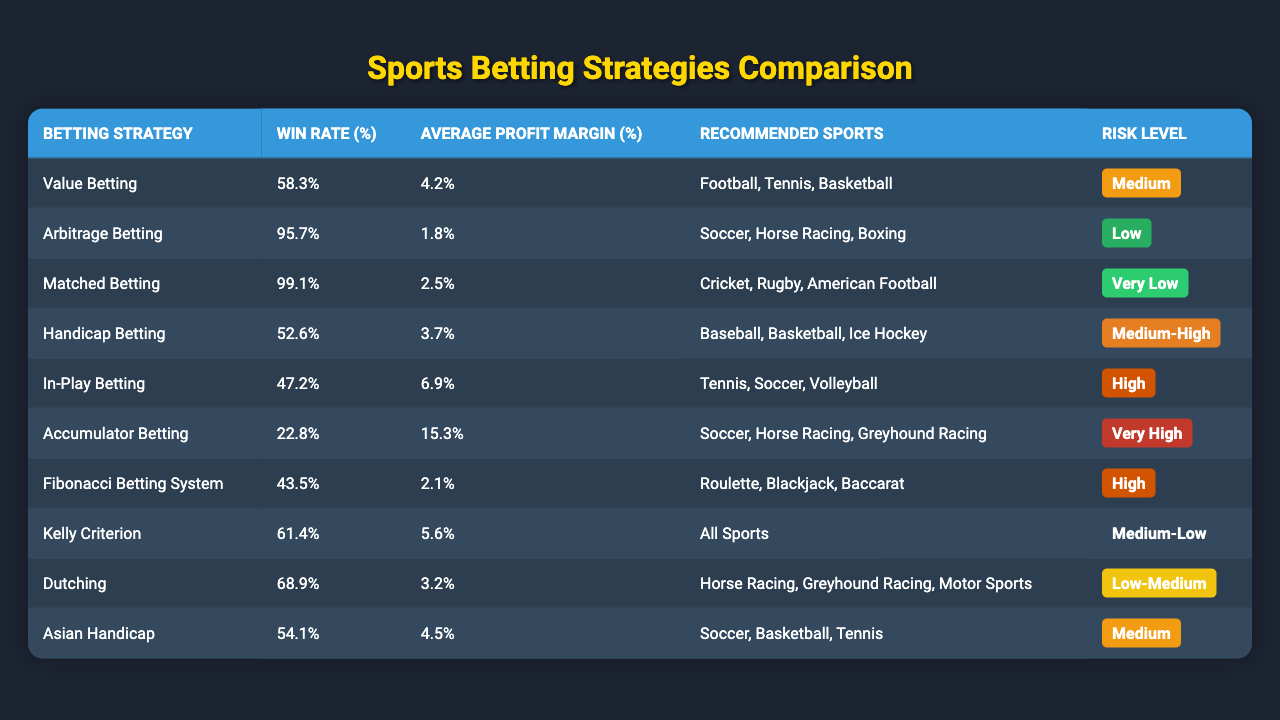What is the win rate of the Matched Betting strategy? The win rate for the Matched Betting strategy is given directly in the table next to its name, which is 99.1%.
Answer: 99.1% Which betting strategy has the highest average profit margin? By comparing the average profit margins listed in the table, the Accumulator Betting strategy has the highest profit margin at 15.3%.
Answer: 15.3% Is the Risk Level for Arbitrage Betting low? The table indicates that the Risk Level for Arbitrage Betting is marked as "Low."
Answer: Yes What is the average win rate for strategies categorized as Low Risk? The win rates for Low Risk strategies are from Arbitrage Betting (95.7%) and Dutching (68.9%). Calculating the average: (95.7 + 68.9) / 2 = 82.3%.
Answer: 82.3% Which betting strategy has the lowest win rate and what is that rate? From the table, the Accumulator Betting strategy has the lowest win rate, at 22.8%.
Answer: 22.8% What are the recommended sports for the Kelly Criterion betting strategy? The table shows that the recommended sports for the Kelly Criterion are "All Sports."
Answer: All Sports If you want a strategy with at least a 60% win rate and medium risk, which one should you choose? Looking at the table, the strategies that meet these criteria are Value Betting (58.3%) and Kelly Criterion (61.4%). The only one that meets both criteria is the Kelly Criterion, which has a win rate of 61.4%.
Answer: Kelly Criterion Which strategy has a win rate of 47.2% and what is its risk level? The In-Play Betting strategy has a win rate of 47.2%, and its risk level is categorized as High according to the table.
Answer: High Are there any betting strategies related to horse racing that have high win rates? The strategies related to horse racing are Arbitrage Betting (95.7%) and Dutching (68.9%), both of which have high win rates.
Answer: Yes What is the difference in win rates between the Matched Betting and Value Betting strategies? The Matched Betting strategy has a win rate of 99.1%, while the Value Betting strategy has a win rate of 58.3%. The difference is calculated as 99.1 - 58.3 = 40.8%.
Answer: 40.8% Is it true that all betting strategies listed have a win rate of over 40%? Examining the table, the only strategy with a win rate below 40% is the Accumulator Betting strategy at 22.8%, so it is false that all strategies have a win rate of over 40%.
Answer: No 